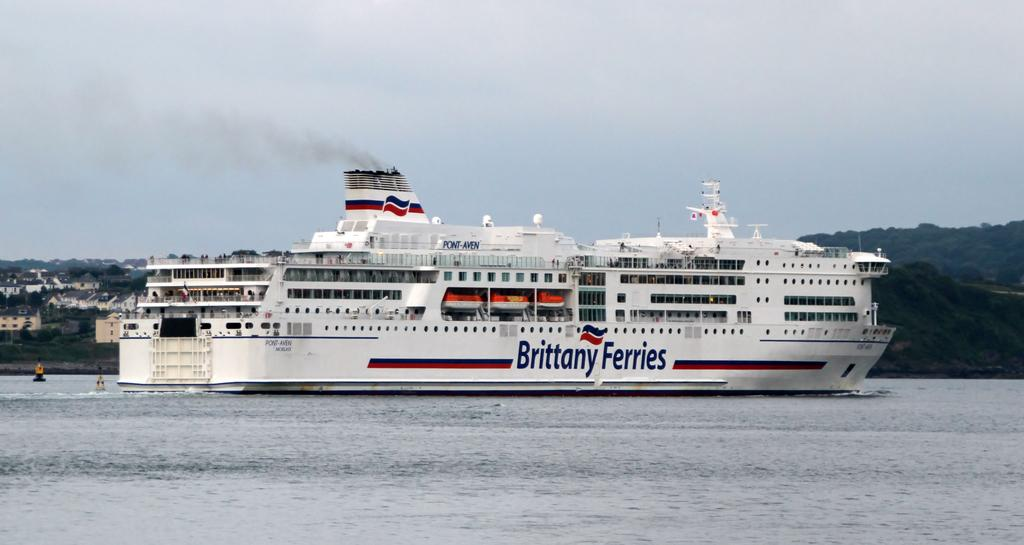What is the main feature of the image? There is water in the image. What type of vehicle can be seen on the water? There is a ship in the image. Are there any other watercraft visible? Yes, there are boats in the image. What type of natural features can be seen in the image? There are trees and mountains in the image. What type of man-made structures are present? There are buildings in the image. What part of the sky is visible in the image? The sky is visible in the image. What type of farm animals can be seen grazing in the image? There are no farm animals present in the image. What type of railway system can be seen in the image? There is no railway system present in the image. 